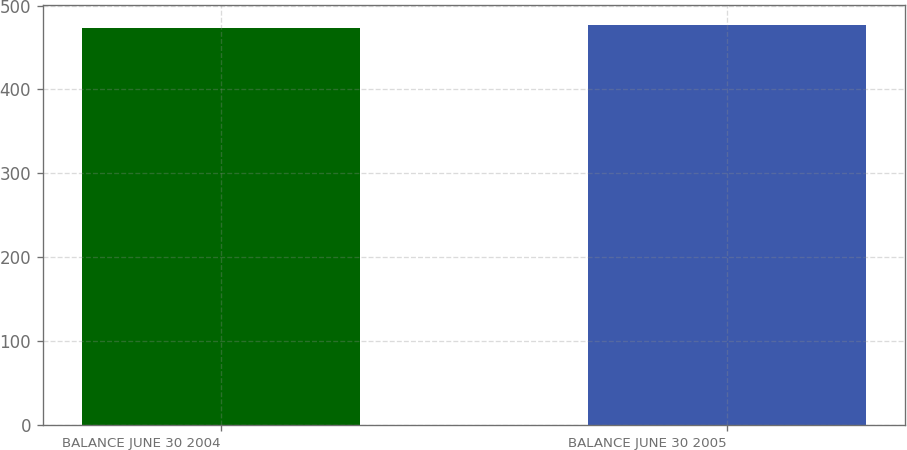<chart> <loc_0><loc_0><loc_500><loc_500><bar_chart><fcel>BALANCE JUNE 30 2004<fcel>BALANCE JUNE 30 2005<nl><fcel>473.1<fcel>476.5<nl></chart> 